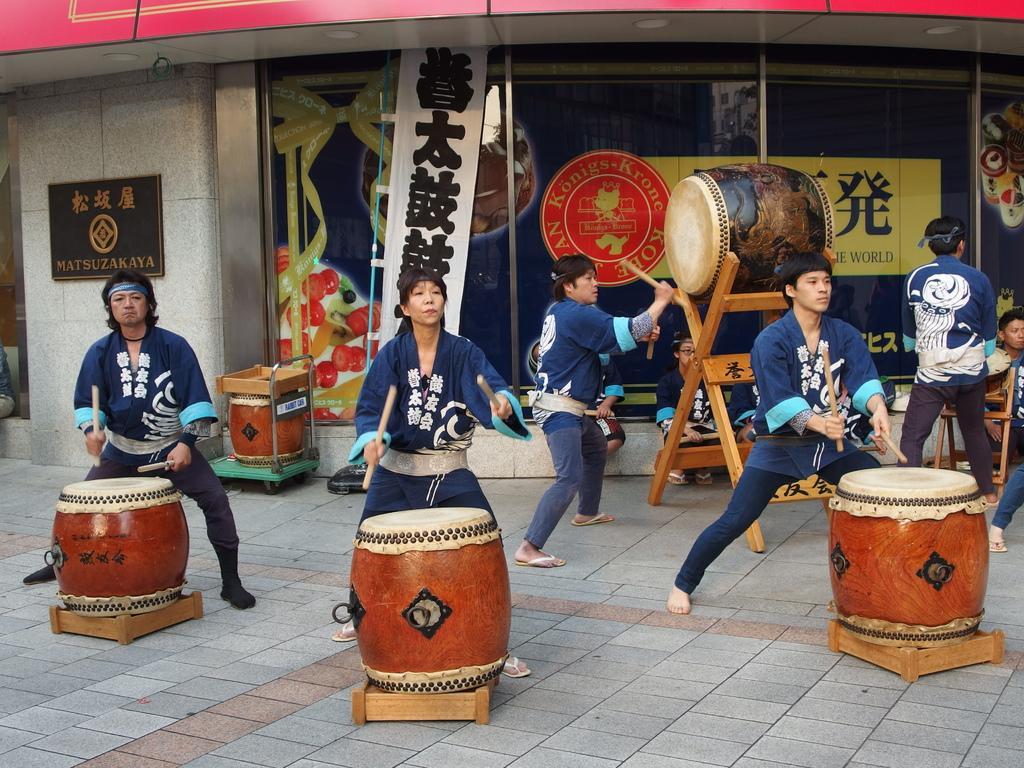Could you give a brief overview of what you see in this image? A band of people are playing drums on a footpath in front of a store. 